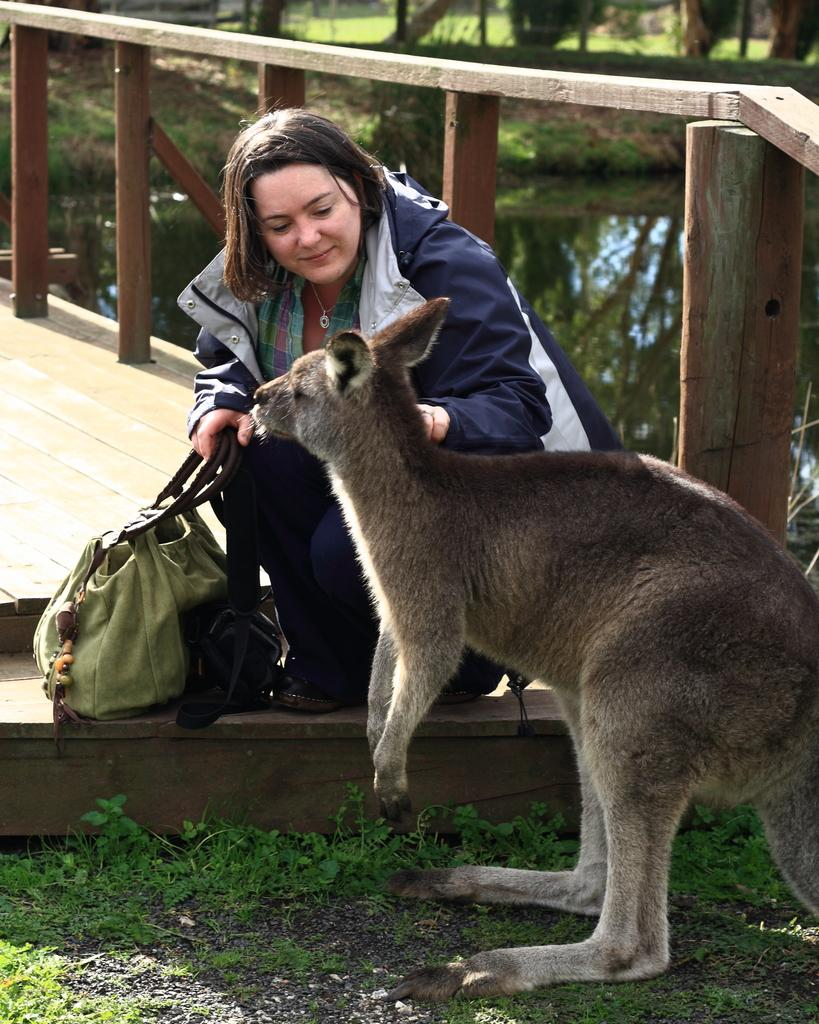What type of animal is in the picture? There is a kangaroo in the picture. What is the woman holding in the picture? The woman is holding a bag in the picture. What object can be seen in the picture besides the kangaroo and the woman? There is a pot in the picture. What type of natural environment is visible in the picture? There are trees visible in the picture. What type of furniture is visible in the picture? There is no furniture present in the image. What type of ornament is hanging from the kangaroo's neck in the picture? There is no ornament hanging from the kangaroo's neck in the image. 